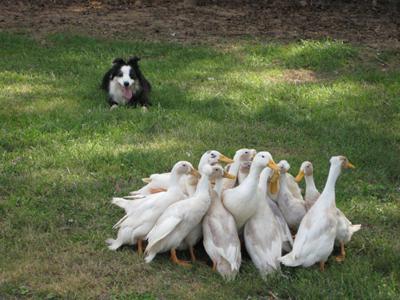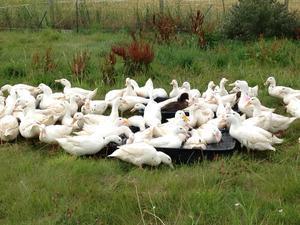The first image is the image on the left, the second image is the image on the right. For the images displayed, is the sentence "One of the images show geese that are all facing left." factually correct? Answer yes or no. No. The first image is the image on the left, the second image is the image on the right. Analyze the images presented: Is the assertion "An image includes at least one long-necked goose with a black neck, and the goose is upright on the grass." valid? Answer yes or no. No. 